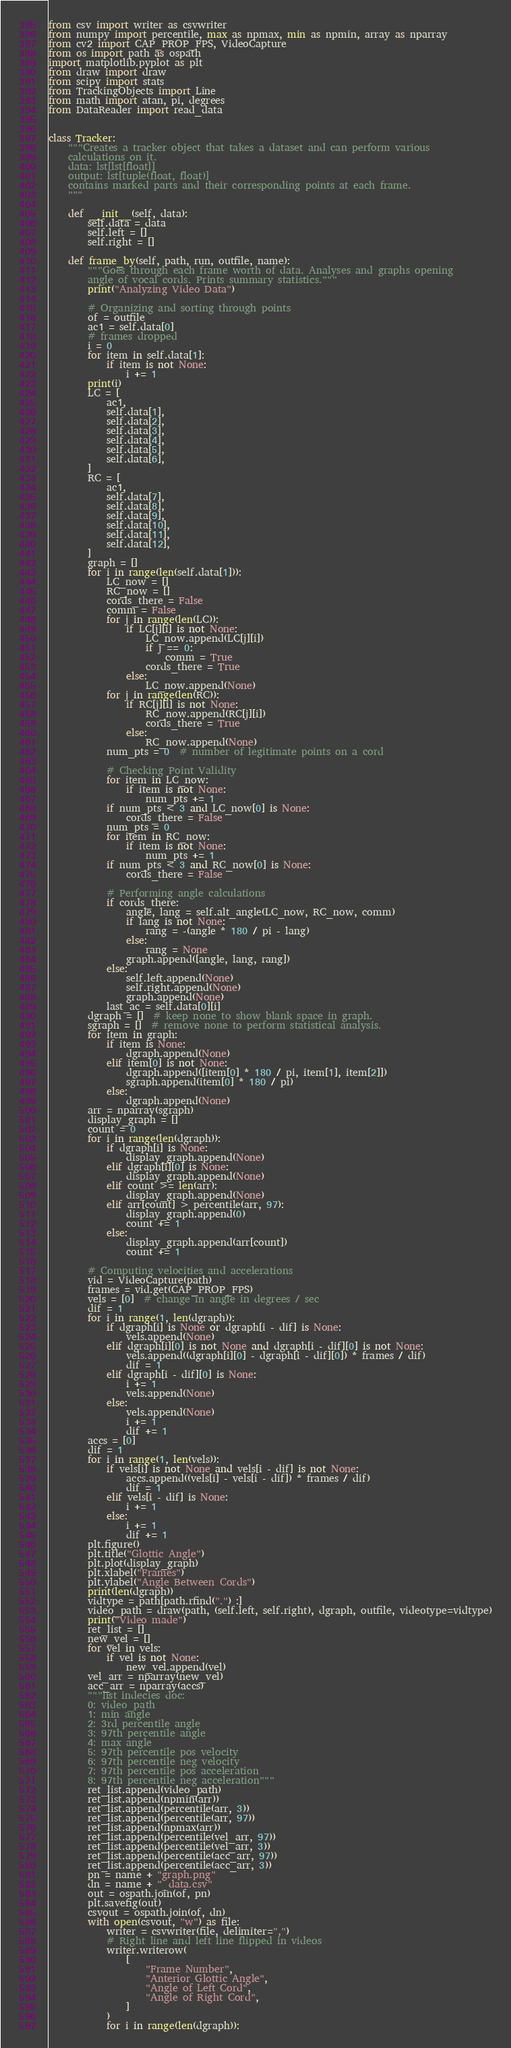Convert code to text. <code><loc_0><loc_0><loc_500><loc_500><_Python_>from csv import writer as csvwriter
from numpy import percentile, max as npmax, min as npmin, array as nparray
from cv2 import CAP_PROP_FPS, VideoCapture
from os import path as ospath
import matplotlib.pyplot as plt
from draw import draw
from scipy import stats
from TrackingObjects import Line
from math import atan, pi, degrees
from DataReader import read_data


class Tracker:
    """Creates a tracker object that takes a dataset and can perform various
    calculations on it.
    data: lst[lst[float]]
    output: lst[tuple(float, float)]
    contains marked parts and their corresponding points at each frame.
    """

    def __init__(self, data):
        self.data = data
        self.left = []
        self.right = []

    def frame_by(self, path, run, outfile, name):
        """Goes through each frame worth of data. Analyses and graphs opening
        angle of vocal cords. Prints summary statistics."""
        print("Analyzing Video Data")

        # Organizing and sorting through points
        of = outfile
        ac1 = self.data[0]
        # frames dropped
        i = 0
        for item in self.data[1]:
            if item is not None:
                i += 1
        print(i)
        LC = [
            ac1,
            self.data[1],
            self.data[2],
            self.data[3],
            self.data[4],
            self.data[5],
            self.data[6],
        ]
        RC = [
            ac1,
            self.data[7],
            self.data[8],
            self.data[9],
            self.data[10],
            self.data[11],
            self.data[12],
        ]
        graph = []
        for i in range(len(self.data[1])):
            LC_now = []
            RC_now = []
            cords_there = False
            comm = False
            for j in range(len(LC)):
                if LC[j][i] is not None:
                    LC_now.append(LC[j][i])
                    if j == 0:
                        comm = True
                    cords_there = True
                else:
                    LC_now.append(None)
            for j in range(len(RC)):
                if RC[j][i] is not None:
                    RC_now.append(RC[j][i])
                    cords_there = True
                else:
                    RC_now.append(None)
            num_pts = 0  # number of legitimate points on a cord

            # Checking Point Validity
            for item in LC_now:
                if item is not None:
                    num_pts += 1
            if num_pts < 3 and LC_now[0] is None:
                cords_there = False
            num_pts = 0
            for item in RC_now:
                if item is not None:
                    num_pts += 1
            if num_pts < 3 and RC_now[0] is None:
                cords_there = False

            # Performing angle calculations
            if cords_there:
                angle, lang = self.alt_angle(LC_now, RC_now, comm)
                if lang is not None:
                    rang = -(angle * 180 / pi - lang)
                else:
                    rang = None
                graph.append([angle, lang, rang])
            else:
                self.left.append(None)
                self.right.append(None)
                graph.append(None)
            last_ac = self.data[0][i]
        dgraph = []  # keep none to show blank space in graph.
        sgraph = []  # remove none to perform statistical analysis.
        for item in graph:
            if item is None:
                dgraph.append(None)
            elif item[0] is not None:
                dgraph.append([item[0] * 180 / pi, item[1], item[2]])
                sgraph.append(item[0] * 180 / pi)
            else:
                dgraph.append(None)
        arr = nparray(sgraph)
        display_graph = []
        count = 0
        for i in range(len(dgraph)):
            if dgraph[i] is None:
                display_graph.append(None)
            elif dgraph[i][0] is None:
                display_graph.append(None)
            elif count >= len(arr):
                display_graph.append(None)
            elif arr[count] > percentile(arr, 97):
                display_graph.append(0)
                count += 1
            else:
                display_graph.append(arr[count])
                count += 1

        # Computing velocities and accelerations
        vid = VideoCapture(path)
        frames = vid.get(CAP_PROP_FPS)
        vels = [0]  # change in angle in degrees / sec
        dif = 1
        for i in range(1, len(dgraph)):
            if dgraph[i] is None or dgraph[i - dif] is None:
                vels.append(None)
            elif dgraph[i][0] is not None and dgraph[i - dif][0] is not None:
                vels.append((dgraph[i][0] - dgraph[i - dif][0]) * frames / dif)
                dif = 1
            elif dgraph[i - dif][0] is None:
                i += 1
                vels.append(None)
            else:
                vels.append(None)
                i += 1
                dif += 1
        accs = [0]
        dif = 1
        for i in range(1, len(vels)):
            if vels[i] is not None and vels[i - dif] is not None:
                accs.append((vels[i] - vels[i - dif]) * frames / dif)
                dif = 1
            elif vels[i - dif] is None:
                i += 1
            else:
                i += 1
                dif += 1
        plt.figure()
        plt.title("Glottic Angle")
        plt.plot(display_graph)
        plt.xlabel("Frames")
        plt.ylabel("Angle Between Cords")
        print(len(dgraph))
        vidtype = path[path.rfind(".") :]
        video_path = draw(path, (self.left, self.right), dgraph, outfile, videotype=vidtype)
        print("Video made")
        ret_list = []
        new_vel = []
        for vel in vels:
            if vel is not None:
                new_vel.append(vel)
        vel_arr = nparray(new_vel)
        acc_arr = nparray(accs)
        """list indecies doc: 
        0: video_path
        1: min angle
        2: 3rd percentile angle
        3: 97th percentile angle
        4: max angle
        5: 97th percentile pos velocity
        6: 97th percentile neg velocity
        7: 97th percentile pos acceleration
        8: 97th percentile neg acceleration"""
        ret_list.append(video_path)
        ret_list.append(npmin(arr))
        ret_list.append(percentile(arr, 3))
        ret_list.append(percentile(arr, 97))
        ret_list.append(npmax(arr))
        ret_list.append(percentile(vel_arr, 97))
        ret_list.append(percentile(vel_arr, 3))
        ret_list.append(percentile(acc_arr, 97))
        ret_list.append(percentile(acc_arr, 3))
        pn = name + "graph.png"
        dn = name + "_data.csv"
        out = ospath.join(of, pn)
        plt.savefig(out)
        csvout = ospath.join(of, dn)
        with open(csvout, "w") as file:
            writer = csvwriter(file, delimiter=",")
            # Right line and left line flipped in videos
            writer.writerow(
                [
                    "Frame Number",
                    "Anterior Glottic Angle",
                    "Angle of Left Cord",
                    "Angle of Right Cord",
                ]
            )
            for i in range(len(dgraph)):</code> 